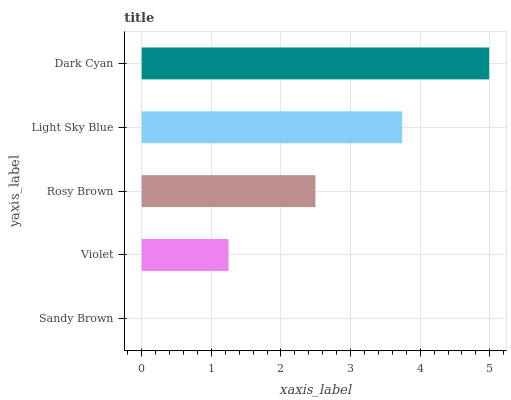Is Sandy Brown the minimum?
Answer yes or no. Yes. Is Dark Cyan the maximum?
Answer yes or no. Yes. Is Violet the minimum?
Answer yes or no. No. Is Violet the maximum?
Answer yes or no. No. Is Violet greater than Sandy Brown?
Answer yes or no. Yes. Is Sandy Brown less than Violet?
Answer yes or no. Yes. Is Sandy Brown greater than Violet?
Answer yes or no. No. Is Violet less than Sandy Brown?
Answer yes or no. No. Is Rosy Brown the high median?
Answer yes or no. Yes. Is Rosy Brown the low median?
Answer yes or no. Yes. Is Sandy Brown the high median?
Answer yes or no. No. Is Dark Cyan the low median?
Answer yes or no. No. 